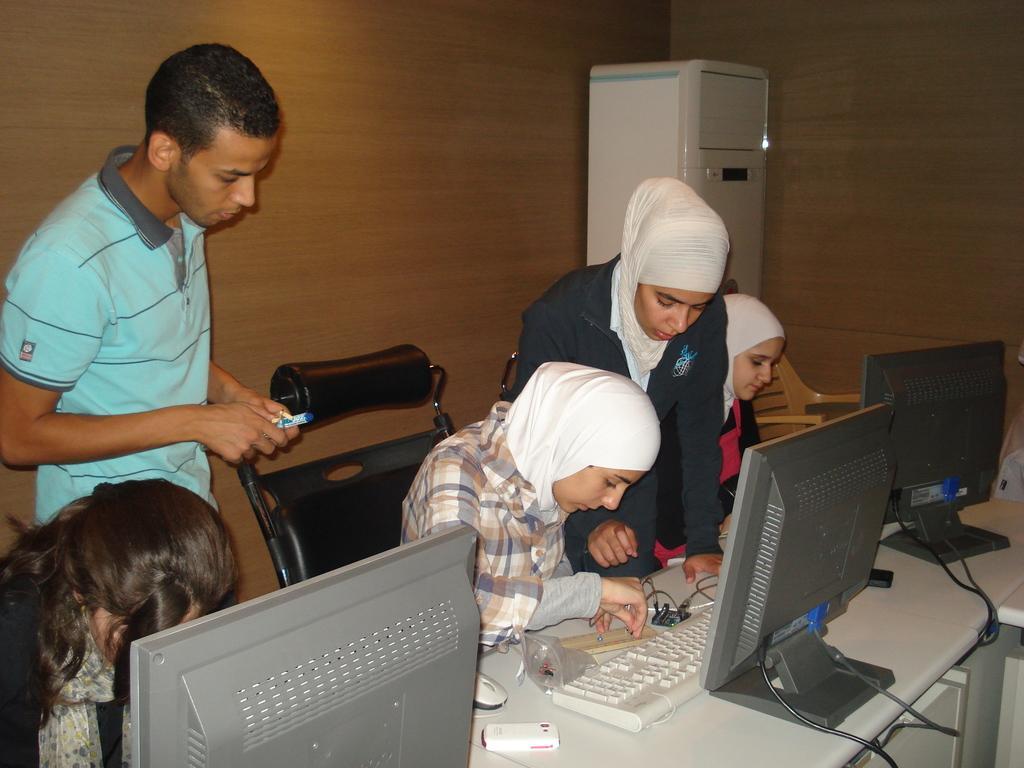Describe this image in one or two sentences. On the background we can see a wall and a machine. Here we can see few persons standing and sitting on chairs in front of a table and on the table we can see monitors, keyboard. We can see a man with blue shirt holding a marker in his hand. 